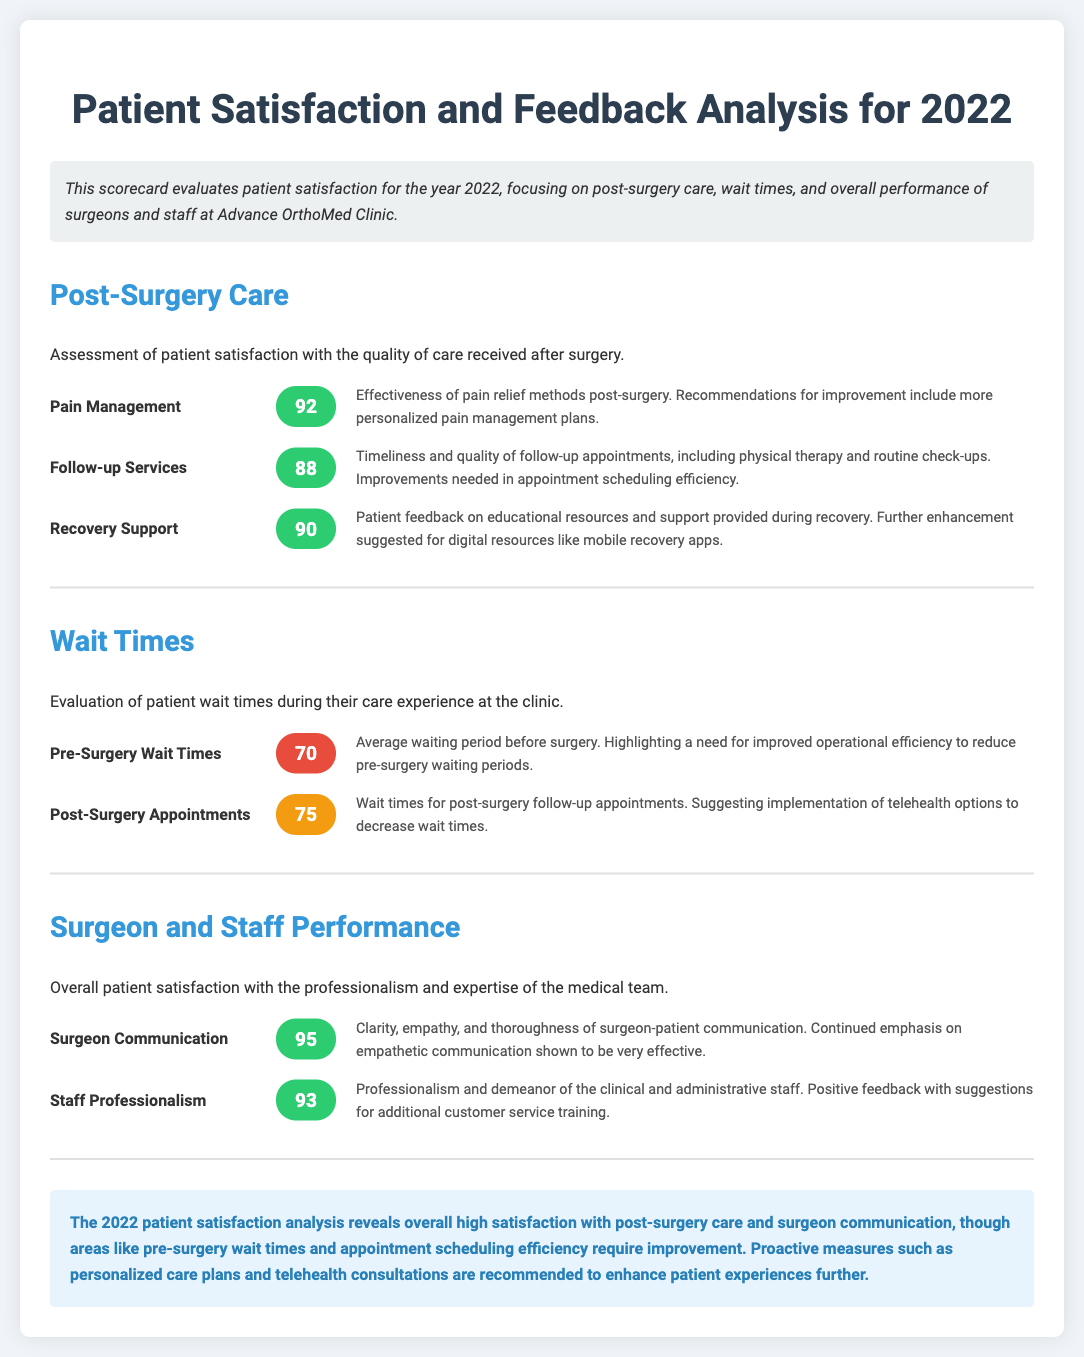What was the score for Pain Management? The score for Pain Management is listed in the Post-Surgery Care section of the document.
Answer: 92 What improvements are suggested for Follow-up Services? The recommendations for Follow-up Services indicate a need for improved appointment scheduling efficiency.
Answer: Appointment scheduling efficiency What is the score for Pre-Surgery Wait Times? The score for Pre-Surgery Wait Times can be found under the Wait Times section.
Answer: 70 What did patients suggest for enhancing Recovery Support? The document states that further enhancement is suggested for digital resources like mobile recovery apps.
Answer: Mobile recovery apps Which aspect of communication received the highest score? The highest score in the Surgeon and Staff Performance section relates to Surgeon Communication.
Answer: 95 What is the score for Staff Professionalism? The score for Staff Professionalism is part of the overall patient satisfaction evaluation in the document.
Answer: 93 What overall area requires improvement based on the conclusion? The conclusion recommends that improved efficiency is needed in certain areas highlighted in the analysis.
Answer: Pre-surgery wait times What type of document is this? The document evaluates patient satisfaction and feedback specifically for a medical clinic.
Answer: Scorecard 